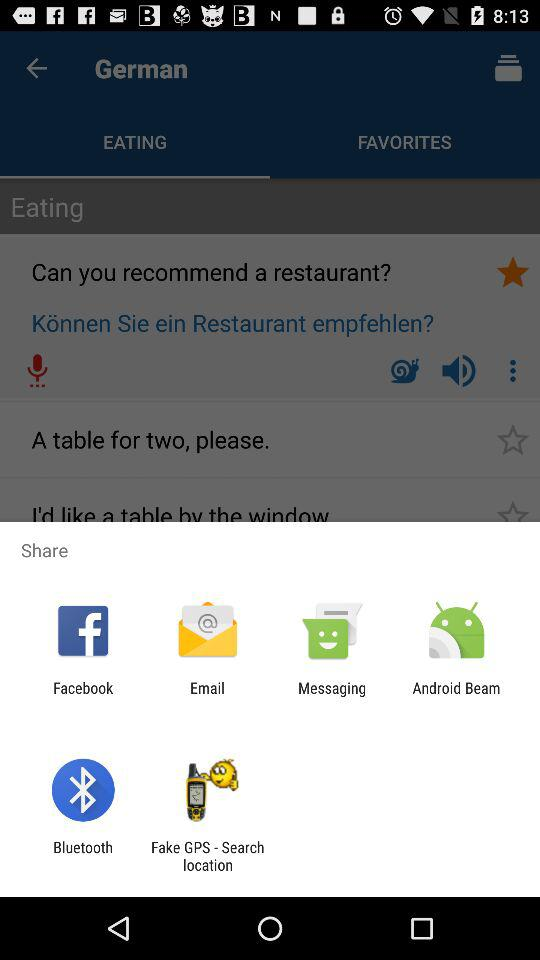What are the options that can be used to share? The options "Facebook", "Email", "Messaging", "Android Beam", "Bluetooth" and "Fake GPS - Search location" can be used to share. 